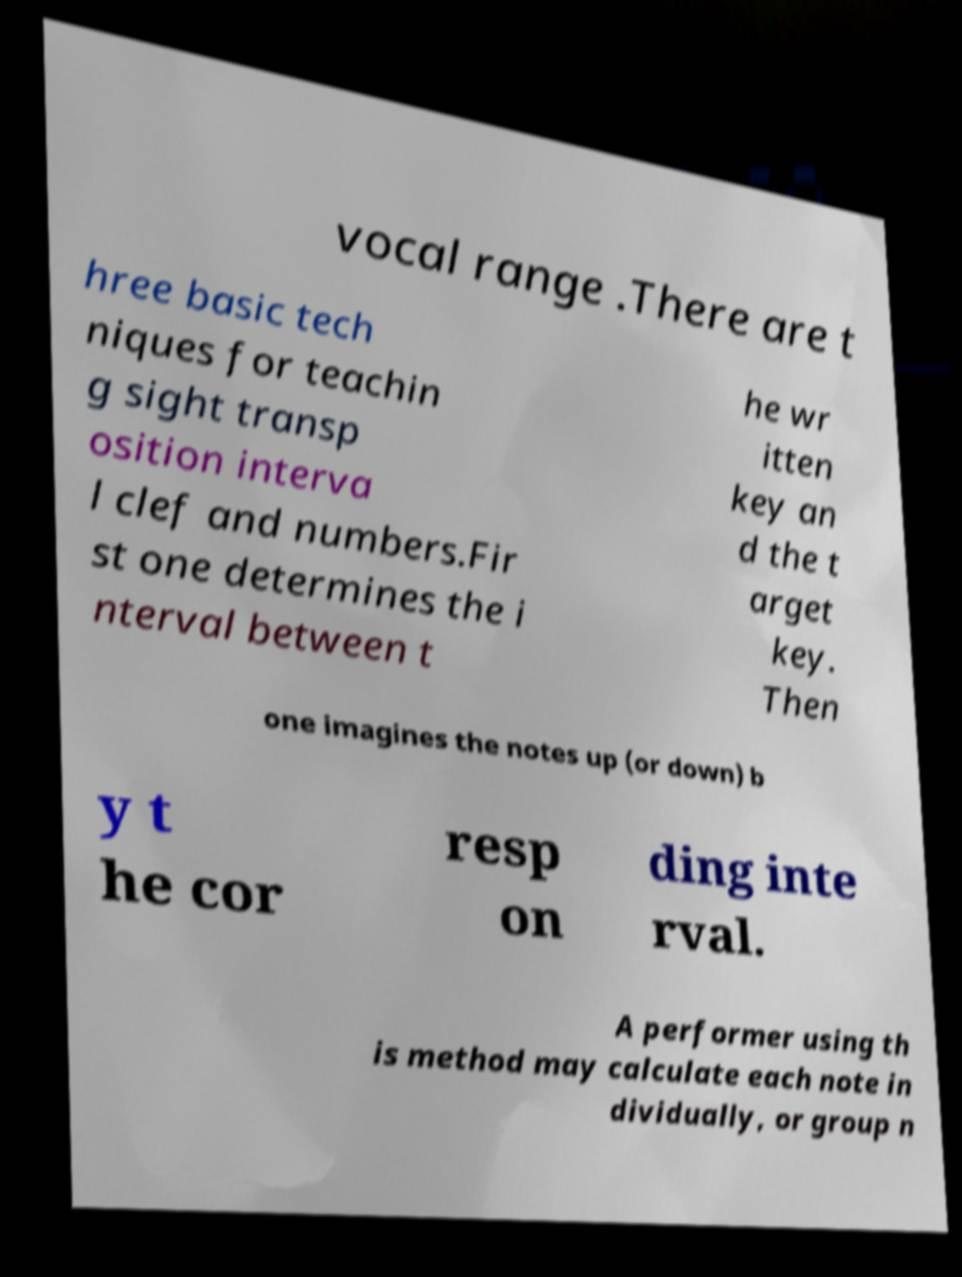Can you read and provide the text displayed in the image?This photo seems to have some interesting text. Can you extract and type it out for me? vocal range .There are t hree basic tech niques for teachin g sight transp osition interva l clef and numbers.Fir st one determines the i nterval between t he wr itten key an d the t arget key. Then one imagines the notes up (or down) b y t he cor resp on ding inte rval. A performer using th is method may calculate each note in dividually, or group n 